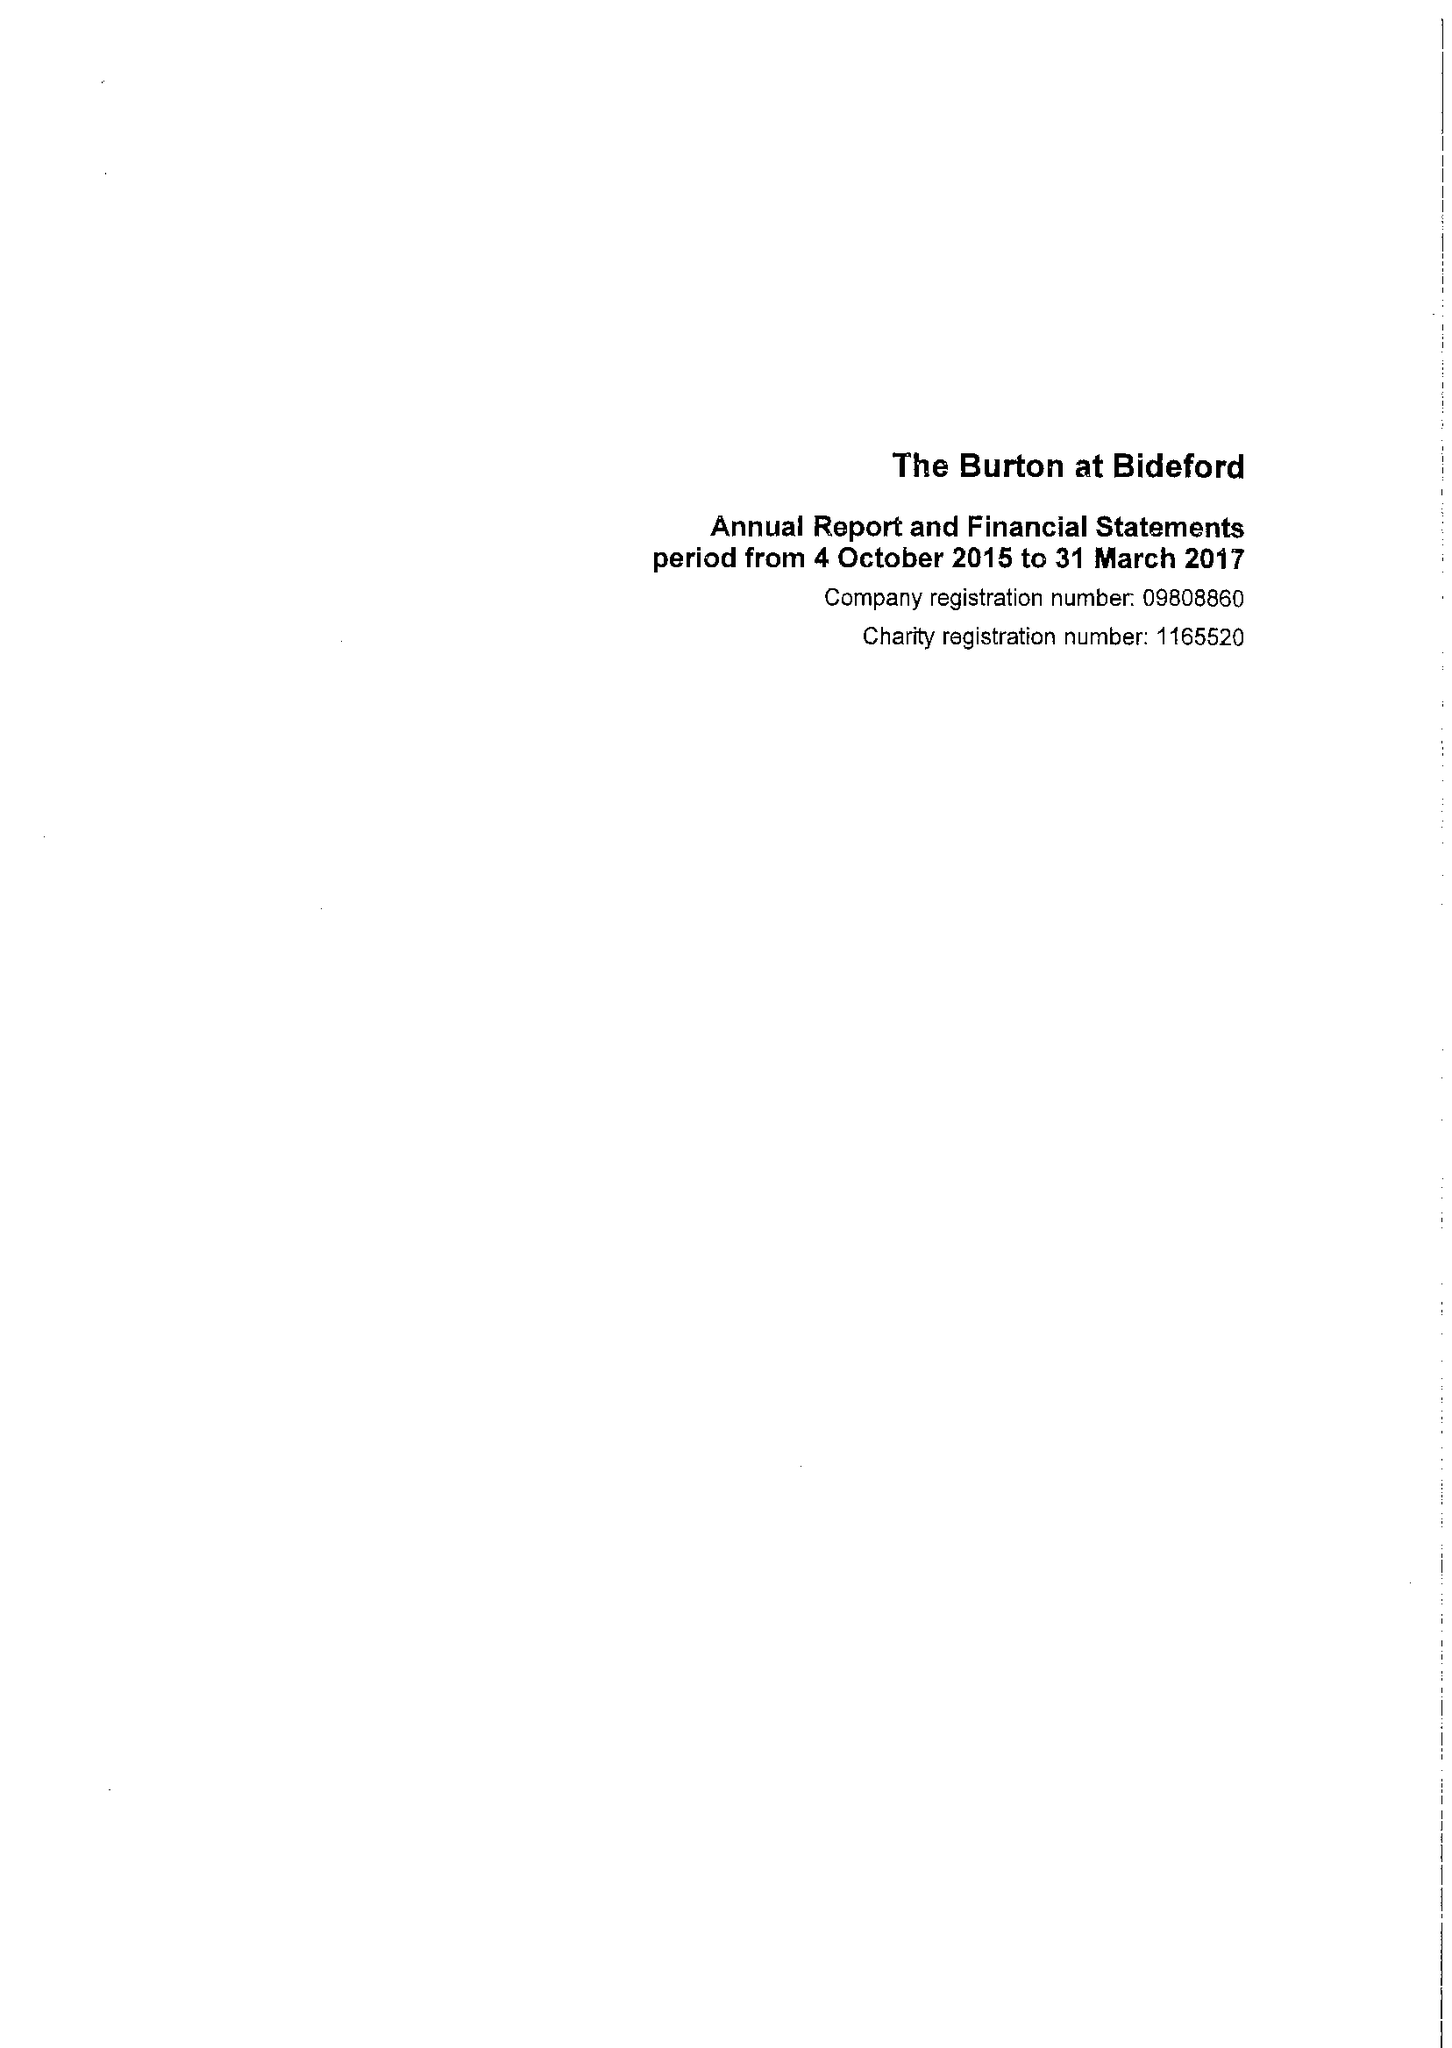What is the value for the address__postcode?
Answer the question using a single word or phrase. EX39 2QQ 